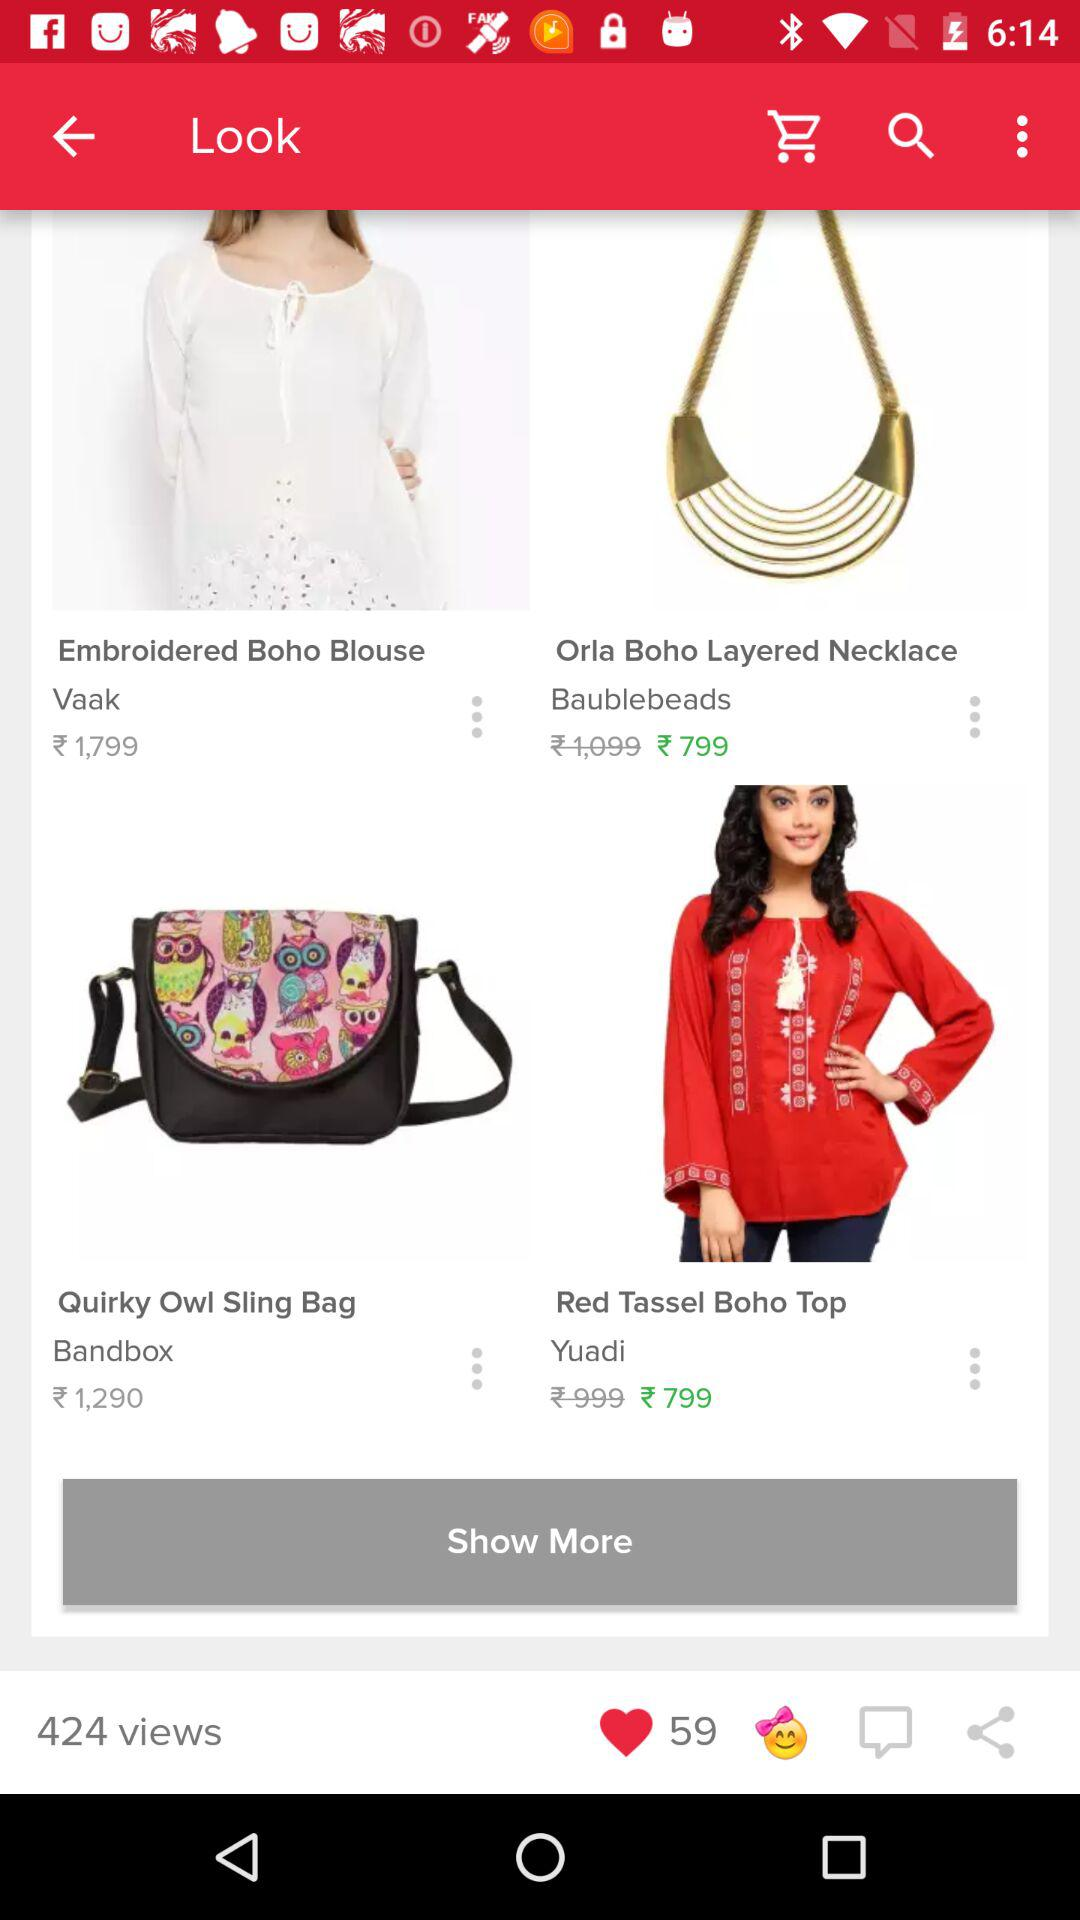How many likes are there? There are 59 likes. 